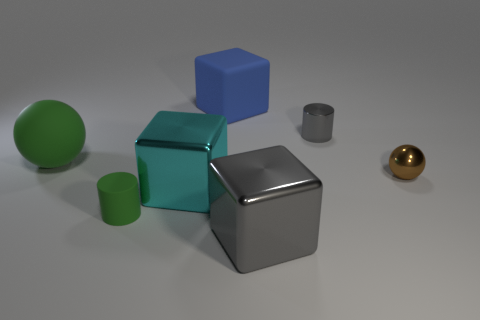Add 1 large metal objects. How many objects exist? 8 Subtract all cylinders. How many objects are left? 5 Subtract 0 purple cubes. How many objects are left? 7 Subtract all tiny green objects. Subtract all big blue matte objects. How many objects are left? 5 Add 3 tiny green cylinders. How many tiny green cylinders are left? 4 Add 5 cyan matte balls. How many cyan matte balls exist? 5 